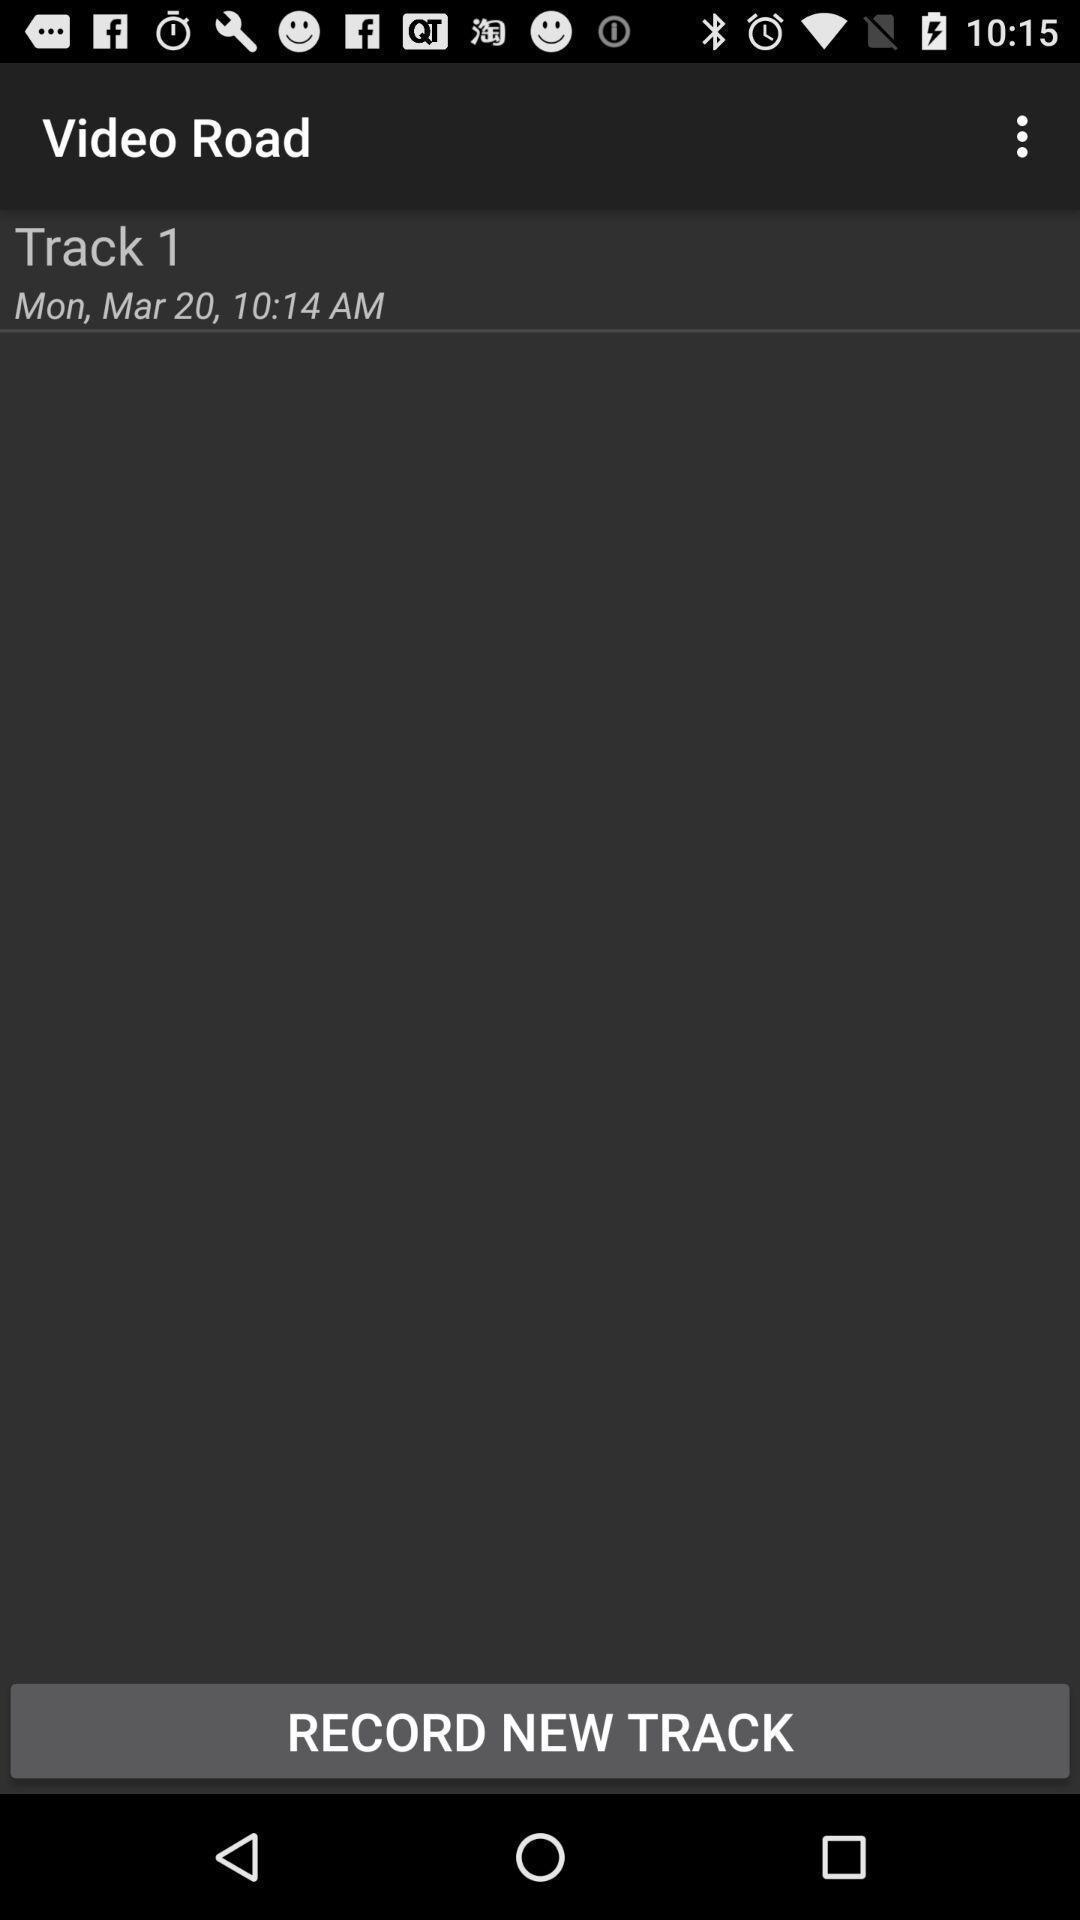Provide a detailed account of this screenshot. Track of the video road in the video app. 